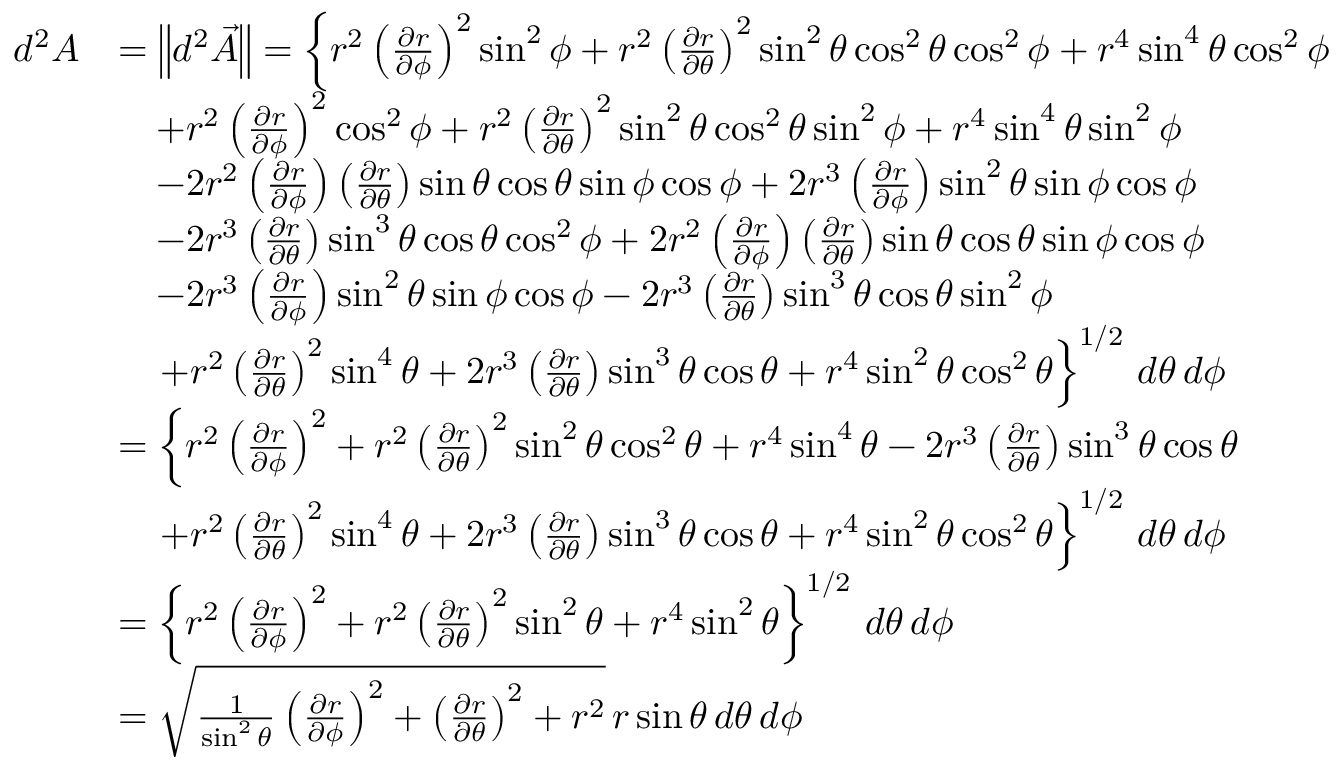Convert formula to latex. <formula><loc_0><loc_0><loc_500><loc_500>\begin{array} { r l } { d ^ { 2 } A } & { = \left \| d ^ { 2 } \vec { A } \right \| = \left \{ r ^ { 2 } \left ( \frac { \partial r } { \partial \phi } \right ) ^ { 2 } \sin ^ { 2 } \phi + r ^ { 2 } \left ( \frac { \partial r } { \partial \theta } \right ) ^ { 2 } \sin ^ { 2 } \theta \cos ^ { 2 } \theta \cos ^ { 2 } \phi + r ^ { 4 } \sin ^ { 4 } \theta \cos ^ { 2 } \phi } \\ & { \quad + r ^ { 2 } \left ( \frac { \partial r } { \partial \phi } \right ) ^ { 2 } \cos ^ { 2 } \phi + r ^ { 2 } \left ( \frac { \partial r } { \partial \theta } \right ) ^ { 2 } \sin ^ { 2 } \theta \cos ^ { 2 } \theta \sin ^ { 2 } \phi + r ^ { 4 } \sin ^ { 4 } \theta \sin ^ { 2 } \phi } \\ & { \quad - 2 r ^ { 2 } \left ( \frac { \partial r } { \partial \phi } \right ) \left ( \frac { \partial r } { \partial \theta } \right ) \sin \theta \cos \theta \sin \phi \cos \phi + 2 r ^ { 3 } \left ( \frac { \partial r } { \partial \phi } \right ) \sin ^ { 2 } \theta \sin \phi \cos \phi } \\ & { \quad - 2 r ^ { 3 } \left ( \frac { \partial r } { \partial \theta } \right ) \sin ^ { 3 } \theta \cos \theta \cos ^ { 2 } \phi + 2 r ^ { 2 } \left ( \frac { \partial r } { \partial \phi } \right ) \left ( \frac { \partial r } { \partial \theta } \right ) \sin \theta \cos \theta \sin \phi \cos \phi } \\ & { \quad - 2 r ^ { 3 } \left ( \frac { \partial r } { \partial \phi } \right ) \sin ^ { 2 } \theta \sin \phi \cos \phi - 2 r ^ { 3 } \left ( \frac { \partial r } { \partial \theta } \right ) \sin ^ { 3 } \theta \cos \theta \sin ^ { 2 } \phi } \\ & { \quad + r ^ { 2 } \left ( \frac { \partial r } { \partial \theta } \right ) ^ { 2 } \sin ^ { 4 } \theta + 2 r ^ { 3 } \left ( \frac { \partial r } { \partial \theta } \right ) \sin ^ { 3 } \theta \cos \theta + r ^ { 4 } \sin ^ { 2 } \theta \cos ^ { 2 } \theta \right \} ^ { 1 / 2 } \, d \theta \, d \phi } \\ & { = \left \{ r ^ { 2 } \left ( \frac { \partial r } { \partial \phi } \right ) ^ { 2 } + r ^ { 2 } \left ( \frac { \partial r } { \partial \theta } \right ) ^ { 2 } \sin ^ { 2 } \theta \cos ^ { 2 } \theta + r ^ { 4 } \sin ^ { 4 } \theta - 2 r ^ { 3 } \left ( \frac { \partial r } { \partial \theta } \right ) \sin ^ { 3 } \theta \cos \theta } \\ & { \quad + r ^ { 2 } \left ( \frac { \partial r } { \partial \theta } \right ) ^ { 2 } \sin ^ { 4 } \theta + 2 r ^ { 3 } \left ( \frac { \partial r } { \partial \theta } \right ) \sin ^ { 3 } \theta \cos \theta + r ^ { 4 } \sin ^ { 2 } \theta \cos ^ { 2 } \theta \right \} ^ { 1 / 2 } \, d \theta \, d \phi } \\ & { = \left \{ r ^ { 2 } \left ( \frac { \partial r } { \partial \phi } \right ) ^ { 2 } + r ^ { 2 } \left ( \frac { \partial r } { \partial \theta } \right ) ^ { 2 } \sin ^ { 2 } \theta + r ^ { 4 } \sin ^ { 2 } \theta \right \} ^ { 1 / 2 } \, d \theta \, d \phi } \\ & { = \sqrt { \frac { 1 } \sin ^ { 2 } \theta } \left ( \frac { \partial r } { \partial \phi } \right ) ^ { 2 } + \left ( \frac { \partial r } { \partial \theta } \right ) ^ { 2 } + r ^ { 2 } } \, r \sin \theta \, d \theta \, d \phi } \end{array}</formula> 